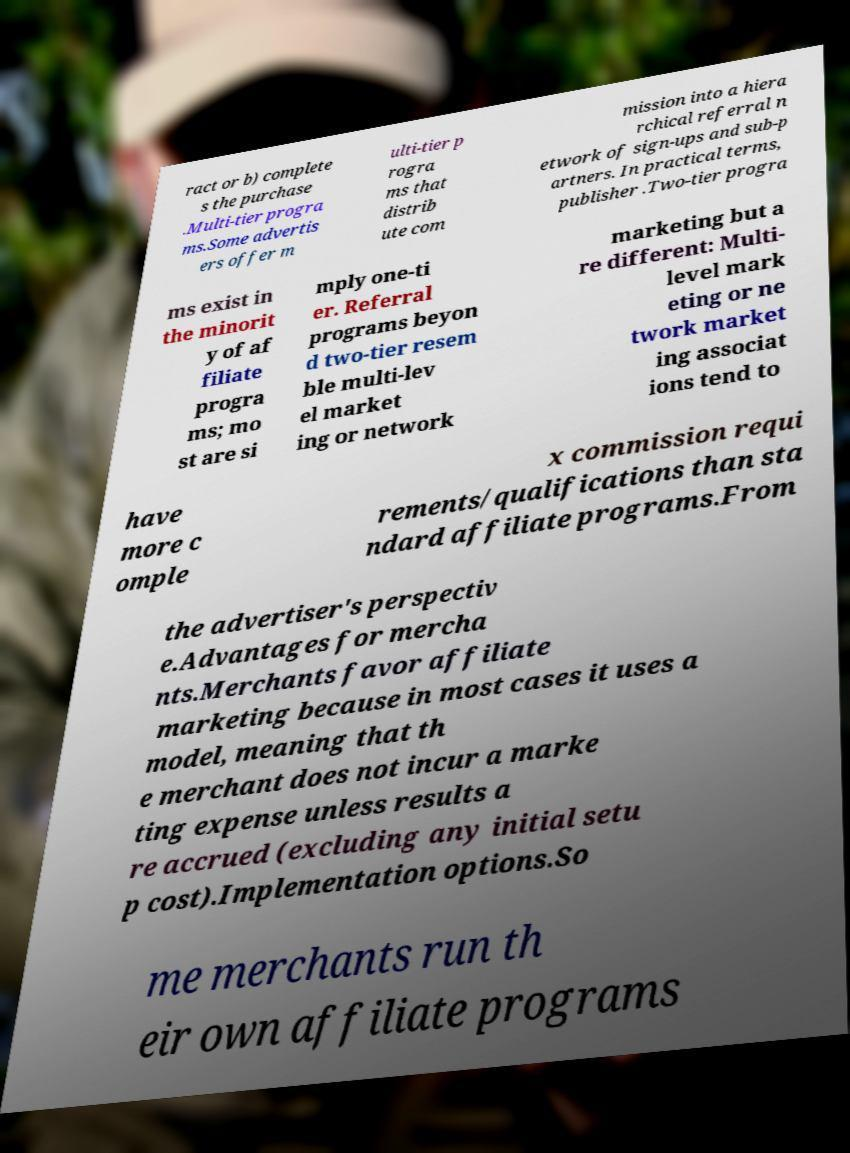What messages or text are displayed in this image? I need them in a readable, typed format. ract or b) complete s the purchase .Multi-tier progra ms.Some advertis ers offer m ulti-tier p rogra ms that distrib ute com mission into a hiera rchical referral n etwork of sign-ups and sub-p artners. In practical terms, publisher .Two-tier progra ms exist in the minorit y of af filiate progra ms; mo st are si mply one-ti er. Referral programs beyon d two-tier resem ble multi-lev el market ing or network marketing but a re different: Multi- level mark eting or ne twork market ing associat ions tend to have more c omple x commission requi rements/qualifications than sta ndard affiliate programs.From the advertiser's perspectiv e.Advantages for mercha nts.Merchants favor affiliate marketing because in most cases it uses a model, meaning that th e merchant does not incur a marke ting expense unless results a re accrued (excluding any initial setu p cost).Implementation options.So me merchants run th eir own affiliate programs 